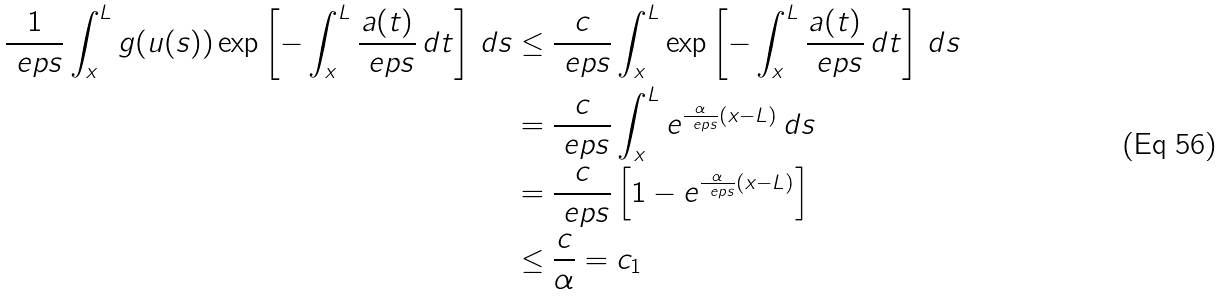<formula> <loc_0><loc_0><loc_500><loc_500>\frac { 1 } { \ e p s } \int _ { x } ^ { L } g ( u ( s ) ) \exp \left [ - \int _ { x } ^ { L } \frac { a ( t ) } { \ e p s } \, d t \right ] \, d s & \leq \frac { c } { \ e p s } \int _ { x } ^ { L } \exp \left [ - \int _ { x } ^ { L } \frac { a ( t ) } { \ e p s } \, d t \right ] \, d s \\ & = \frac { c } { \ e p s } \int _ { x } ^ { L } e ^ { \frac { \alpha } { \ e p s } ( x - L ) } \, d s \\ & = \frac { c } { \ e p s } \left [ 1 - e ^ { \frac { \alpha } { \ e p s } ( x - L ) } \right ] \\ & \leq \frac { c } { \alpha } = c _ { 1 } \\</formula> 